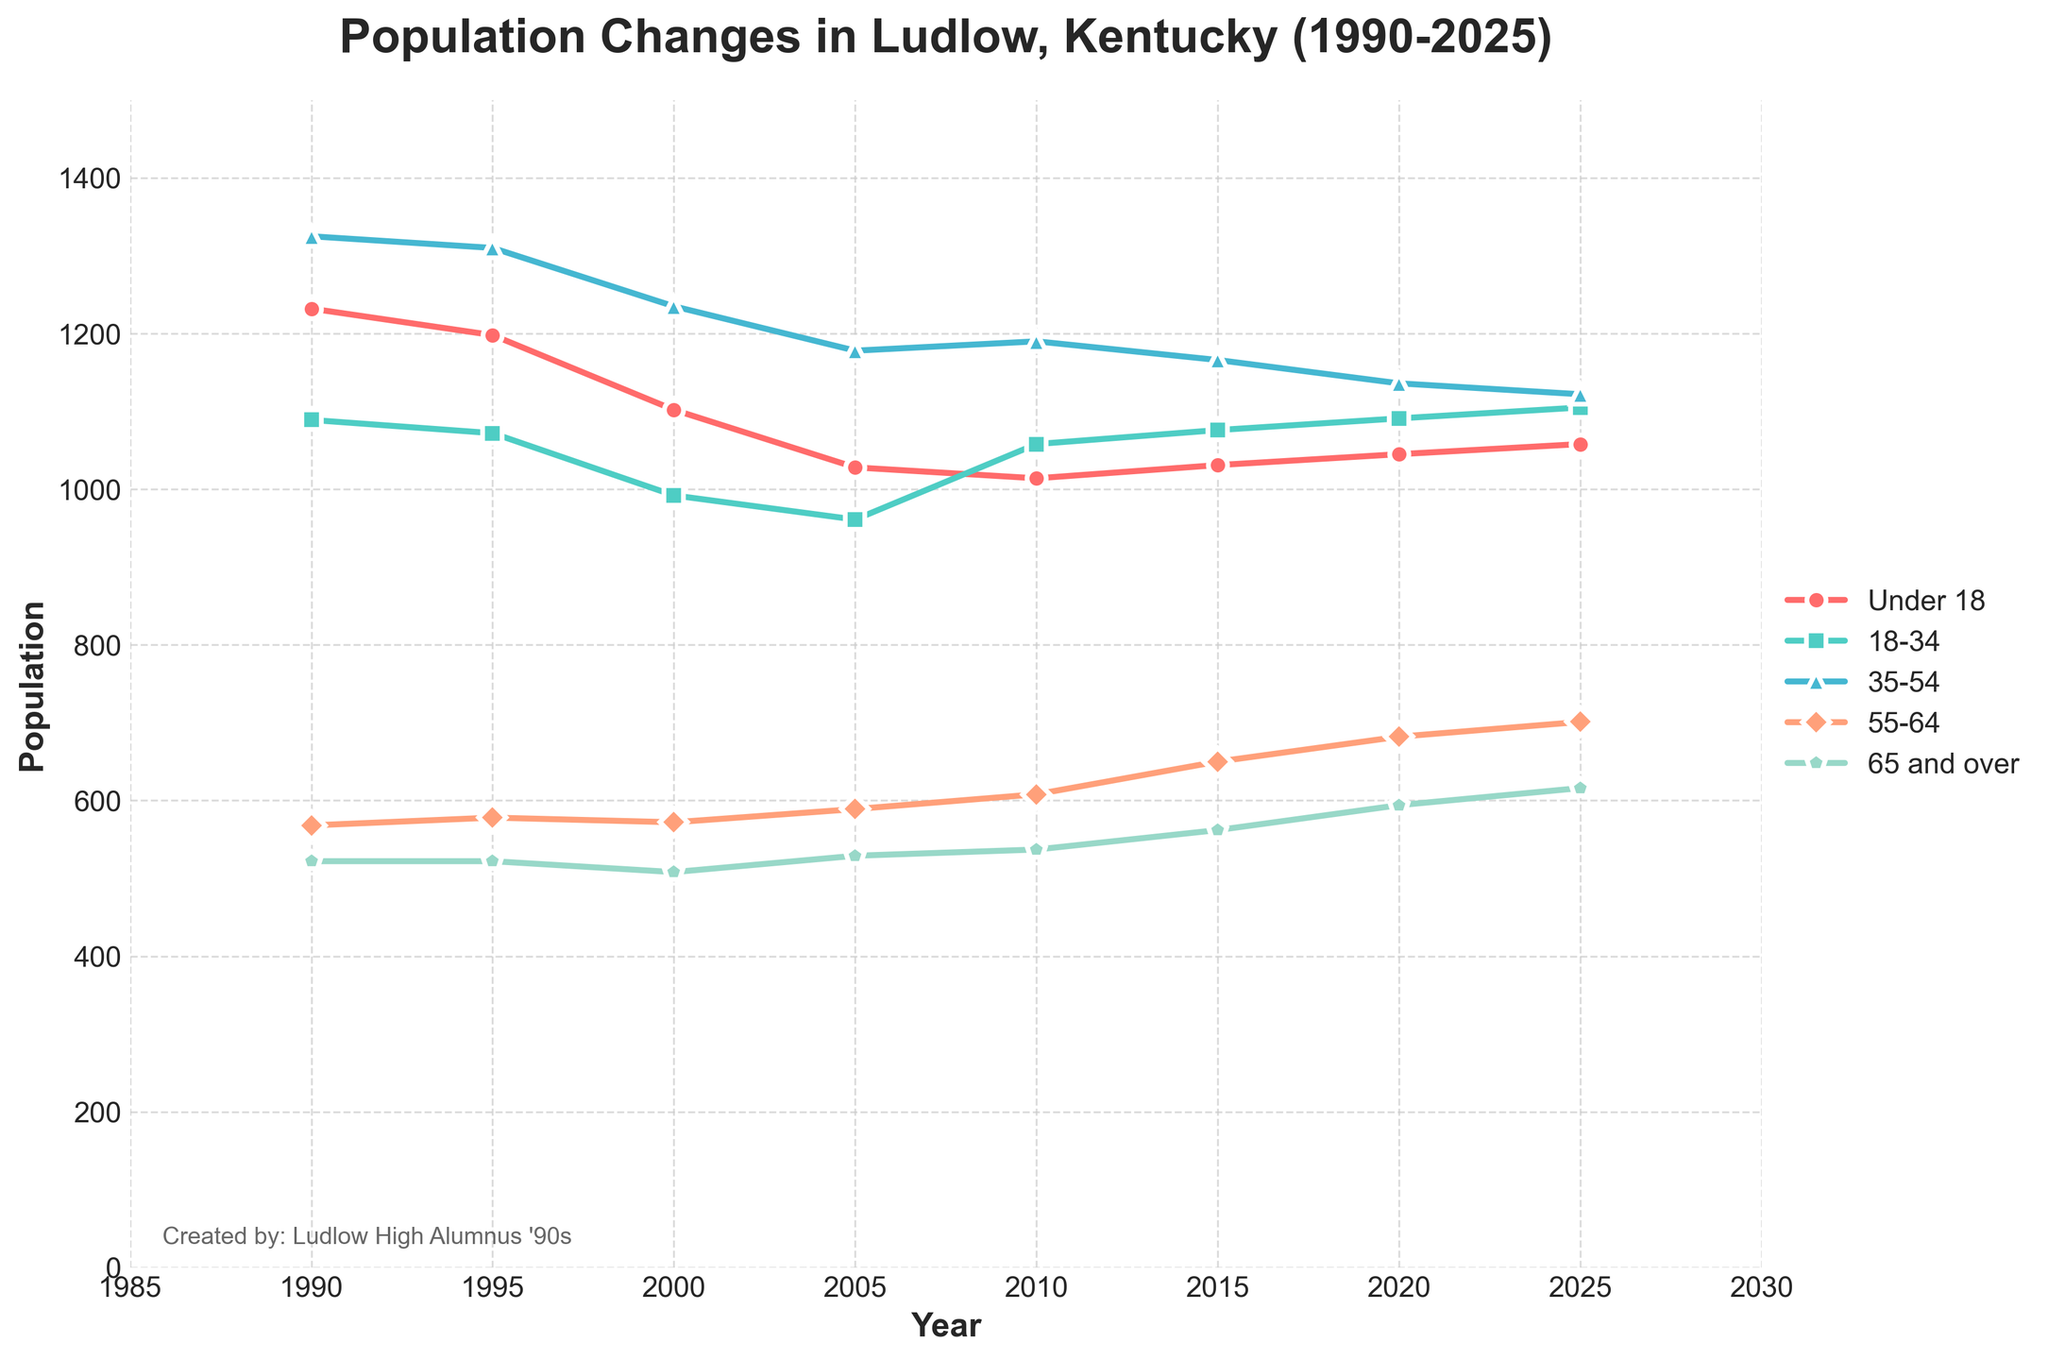Which age group had the highest population in 1990? The highest segment in 1990 can be found by examining the y-values for each age group. The group with the highest value is '35-54' with 1325.
Answer: '35-54' with 1325 How did the total population change from 1990 to 2020? Subtract the total population in 1990 from that in 2020: 4548 (2020) - 4736 (1990) = -188. The total population decreased by 188 individuals from 1990 to 2020.
Answer: Decreased by 188 Which age group showed an increase in population between 2000 and 2020? By comparing data from 2000 and 2020 for each age group: 'Under 18' (1102 to 1045, decrease), '18-34' (992 to 1091, increase), '35-54' (1235 to 1136, decrease), '55-64' (572 to 682, increase), '65 and over' (508 to 594, increase). The groups '18-34', '55-64', and '65 and over' showed an increase.
Answer: '18-34', '55-64', '65 and over' What is the average population of the '55-64' age group over the years provided? Sum the populations of '55-64' for all the years: 568 + 578 + 572 + 589 + 608 + 650 + 682 + 701 = 4948. Divide by the number of years: 4948 / 8 = 618.5.
Answer: 618.5 Which age group showed the most stable population trend from 1990 to 2025? Comparing the fluctuations, '65 and over' shows the least variability with gradual increments: 522 (1990), 522 (1995), 508 (2000), 529 (2005), 537 (2010), 562 (2015), 594 (2020), 616 (2025).
Answer: '65 and over' Visualize and compare the colors of 'Under 18' and '35-54' age groups. Which color represents 'Under 18'? The 'Under 18' age group is represented by a red line, while '35-54' is represented by a blue line. The distinguishing color is red.
Answer: Red In which year did the '18-34' age group surpass 1000 again after 1990? By examining the data, '18-34' surpasses the 1000 mark in 2010: '18-34' rose to 1058 in 2010, after having dipped to numbers below 1000 in 2000 and 2005.
Answer: 2010 How many years did the '35-54' age group decrease consecutively from its peak in 1990? The peak is in 1990 with 1325. A decrease is seen in subsequent years till 2025: 1990 to 2000, 1995 to 2005, 2000 to 2020, and 2005 to 2025. Four consecutive periods show a decrease.
Answer: Four periods Which age group had the smallest population in 2020? In 2020, 'Under 18' had the smallest population with 1045, below the populations of the other age groups.
Answer: 'Under 18' 